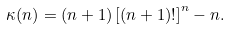<formula> <loc_0><loc_0><loc_500><loc_500>\kappa ( n ) = ( n + 1 ) \left [ ( n + 1 ) ! \right ] ^ { n } - n .</formula> 